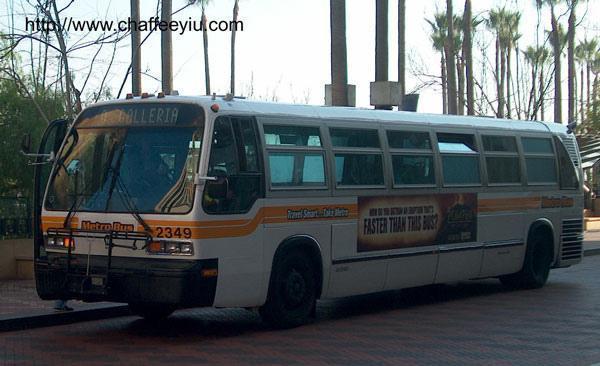How many people are in this vehicle?
Give a very brief answer. 0. 